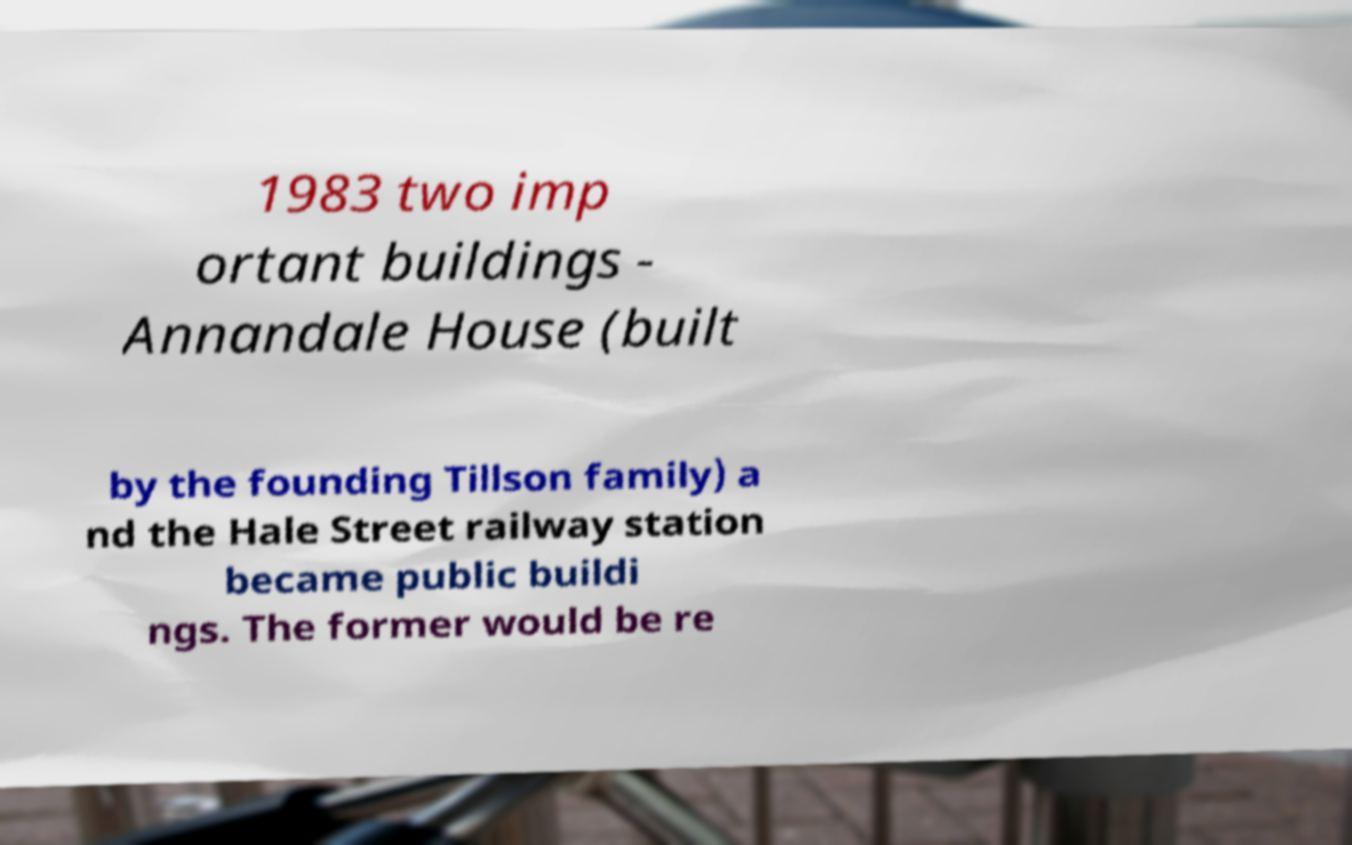Can you accurately transcribe the text from the provided image for me? 1983 two imp ortant buildings - Annandale House (built by the founding Tillson family) a nd the Hale Street railway station became public buildi ngs. The former would be re 